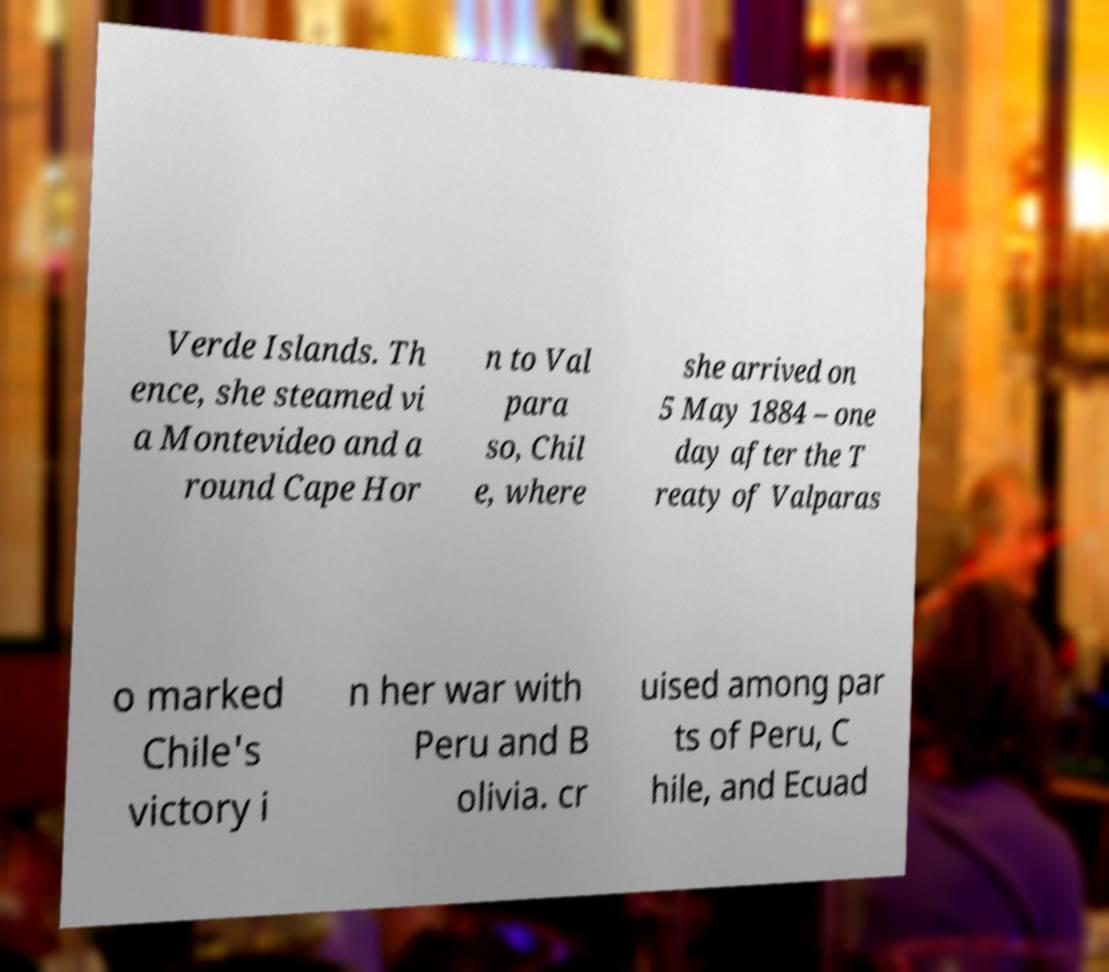Can you accurately transcribe the text from the provided image for me? Verde Islands. Th ence, she steamed vi a Montevideo and a round Cape Hor n to Val para so, Chil e, where she arrived on 5 May 1884 – one day after the T reaty of Valparas o marked Chile's victory i n her war with Peru and B olivia. cr uised among par ts of Peru, C hile, and Ecuad 